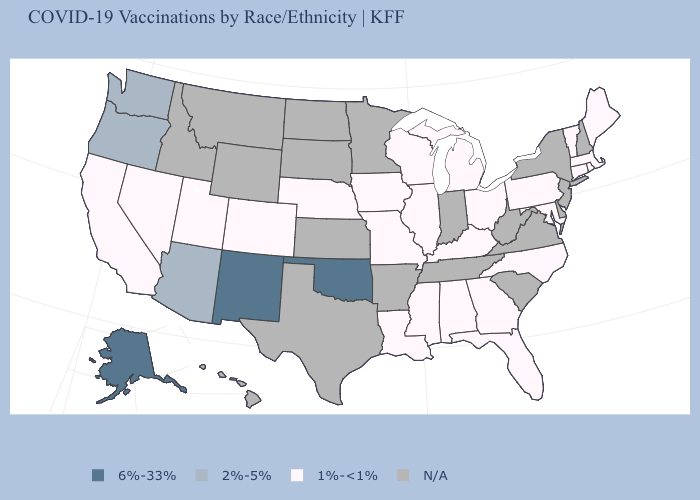What is the value of Delaware?
Write a very short answer. N/A. Which states hav the highest value in the MidWest?
Answer briefly. Illinois, Iowa, Michigan, Missouri, Nebraska, Ohio, Wisconsin. Among the states that border New Mexico , which have the highest value?
Write a very short answer. Oklahoma. What is the highest value in the West ?
Write a very short answer. 6%-33%. Name the states that have a value in the range N/A?
Be succinct. Arkansas, Delaware, Hawaii, Idaho, Indiana, Kansas, Minnesota, Montana, New Hampshire, New Jersey, New York, North Dakota, South Carolina, South Dakota, Tennessee, Texas, Virginia, West Virginia, Wyoming. Among the states that border Vermont , which have the lowest value?
Write a very short answer. Massachusetts. Name the states that have a value in the range N/A?
Be succinct. Arkansas, Delaware, Hawaii, Idaho, Indiana, Kansas, Minnesota, Montana, New Hampshire, New Jersey, New York, North Dakota, South Carolina, South Dakota, Tennessee, Texas, Virginia, West Virginia, Wyoming. What is the highest value in the USA?
Answer briefly. 6%-33%. What is the highest value in states that border Tennessee?
Keep it brief. 1%-<1%. Among the states that border Washington , which have the lowest value?
Short answer required. Oregon. What is the value of New Mexico?
Be succinct. 6%-33%. Does the first symbol in the legend represent the smallest category?
Short answer required. No. What is the value of Pennsylvania?
Short answer required. 1%-<1%. How many symbols are there in the legend?
Quick response, please. 4. 